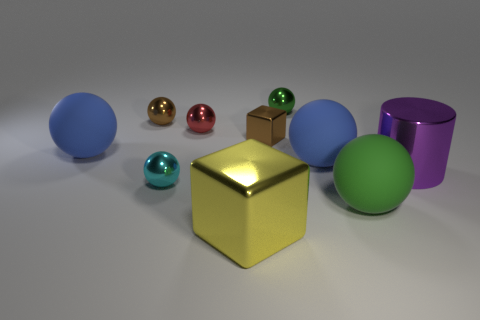What number of things are either green things or rubber objects that are to the left of the yellow object? Counting the objects that are either green or have the rubber-like appearance, and are to the left of the yellow cube, yields a total of 2 objects. The green sphere and the blue rubber-like sphere meet these criteria. 